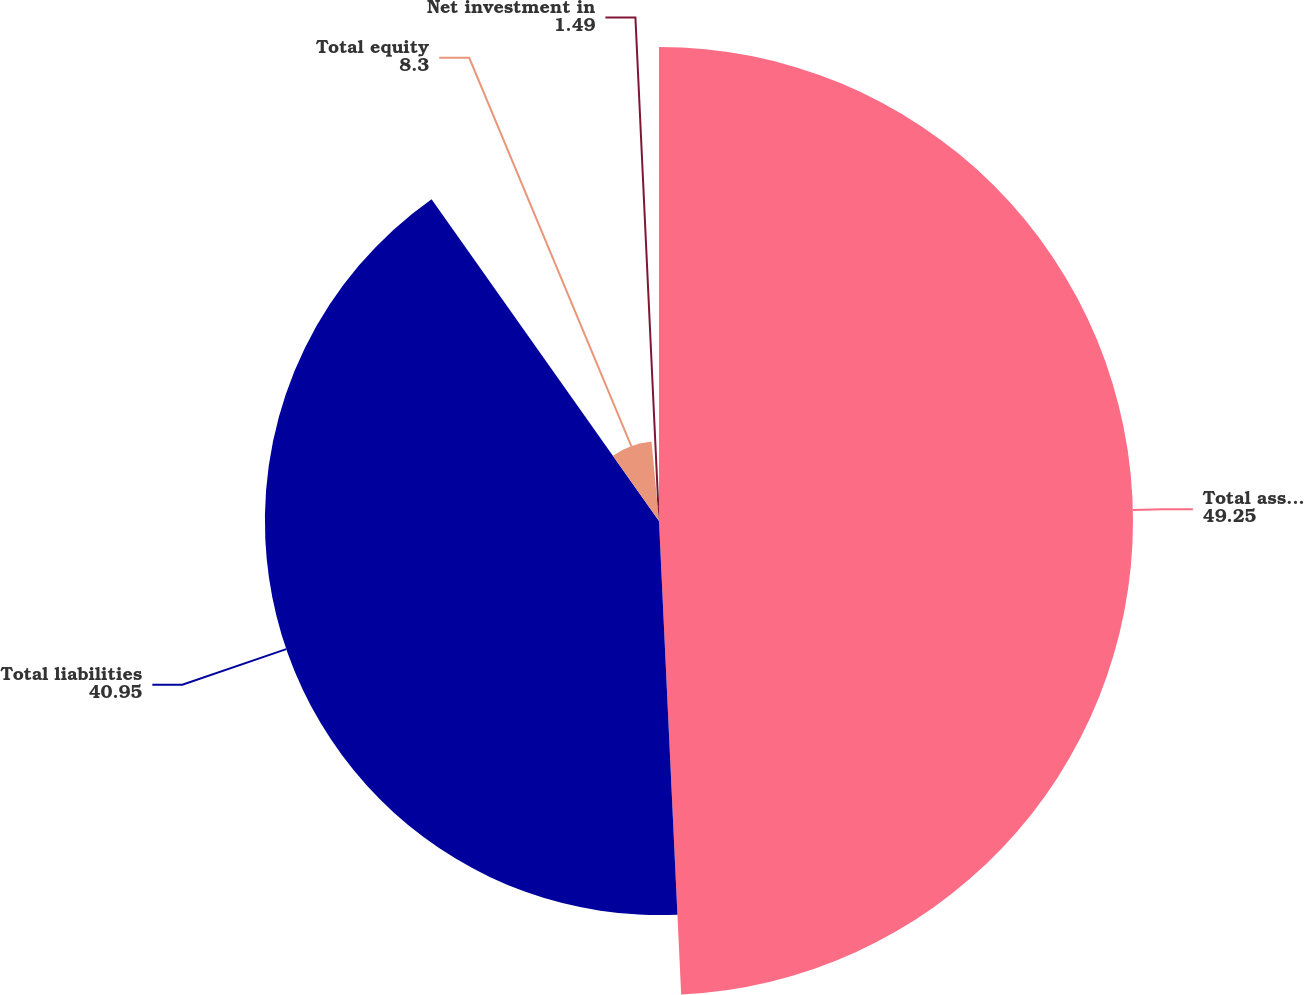<chart> <loc_0><loc_0><loc_500><loc_500><pie_chart><fcel>Total assets<fcel>Total liabilities<fcel>Total equity<fcel>Net investment in<nl><fcel>49.25%<fcel>40.95%<fcel>8.3%<fcel>1.49%<nl></chart> 